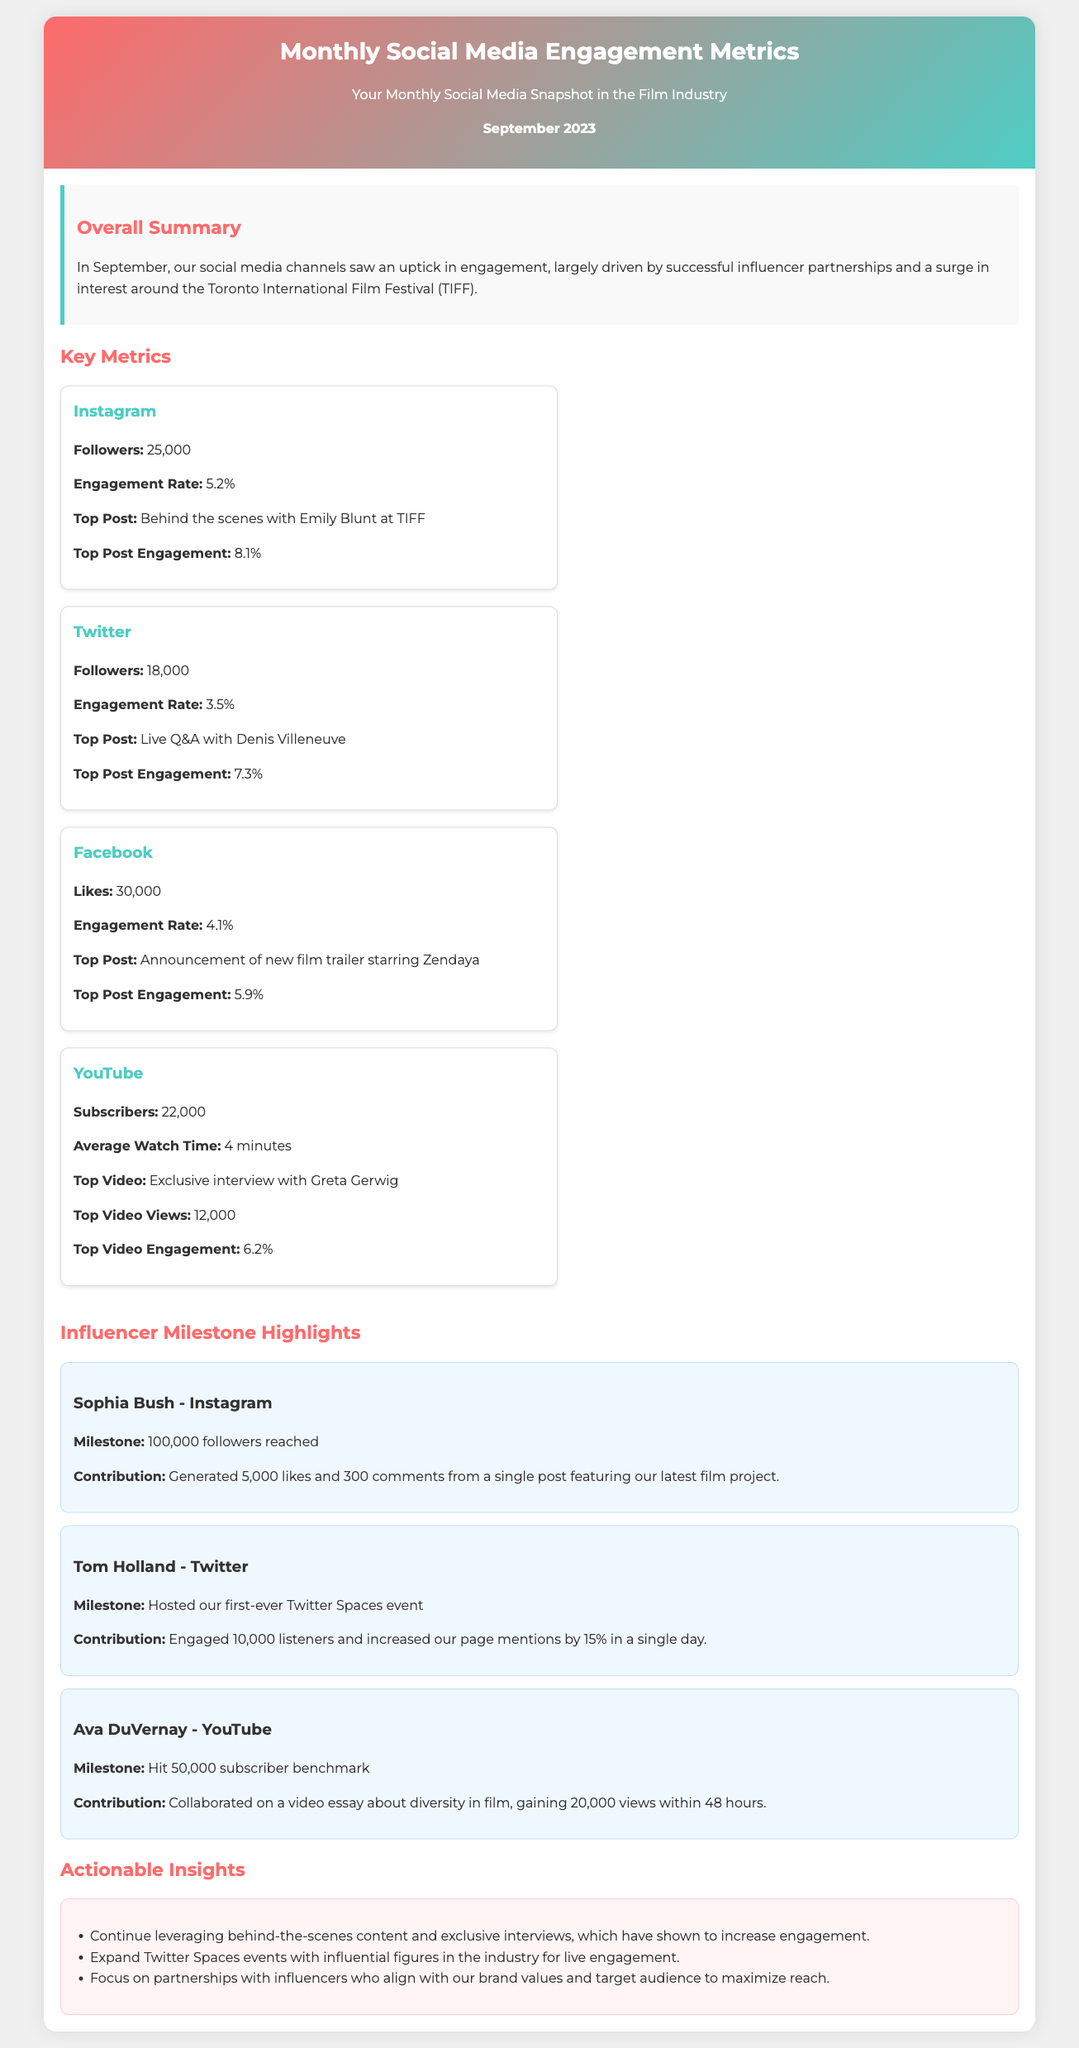what was the total number of followers on Instagram? The total number of followers on Instagram is listed in the document under key metrics, which states 25,000.
Answer: 25,000 what is the engagement rate for Twitter? The engagement rate for Twitter is mentioned in the metrics section, which specifies it as 3.5%.
Answer: 3.5% who was featured in the top post on Facebook? The document states that the top post on Facebook was an announcement of a new film trailer starring Zendaya.
Answer: Zendaya how many views did the top video on YouTube receive? The total views for the top video on YouTube are noted as 12,000 in the metrics section of the document.
Answer: 12,000 which influencer reached 100,000 followers on Instagram? According to the influencer milestones highlighted in the document, Sophia Bush is the influencer who reached 100,000 followers.
Answer: Sophia Bush how many listeners engaged during the Twitter Spaces event hosted by Tom Holland? The document provides the number of listeners during the Twitter Spaces event, which was 10,000.
Answer: 10,000 what was the top post engagement rate on Instagram? The top post engagement rate for Instagram is mentioned in the metrics as 8.1%.
Answer: 8.1% what action is suggested to increase engagement with influencers? The actionable insights section recommends focusing on partnerships with influencers who align with our brand values.
Answer: partnerships with influencers who align with our brand values 